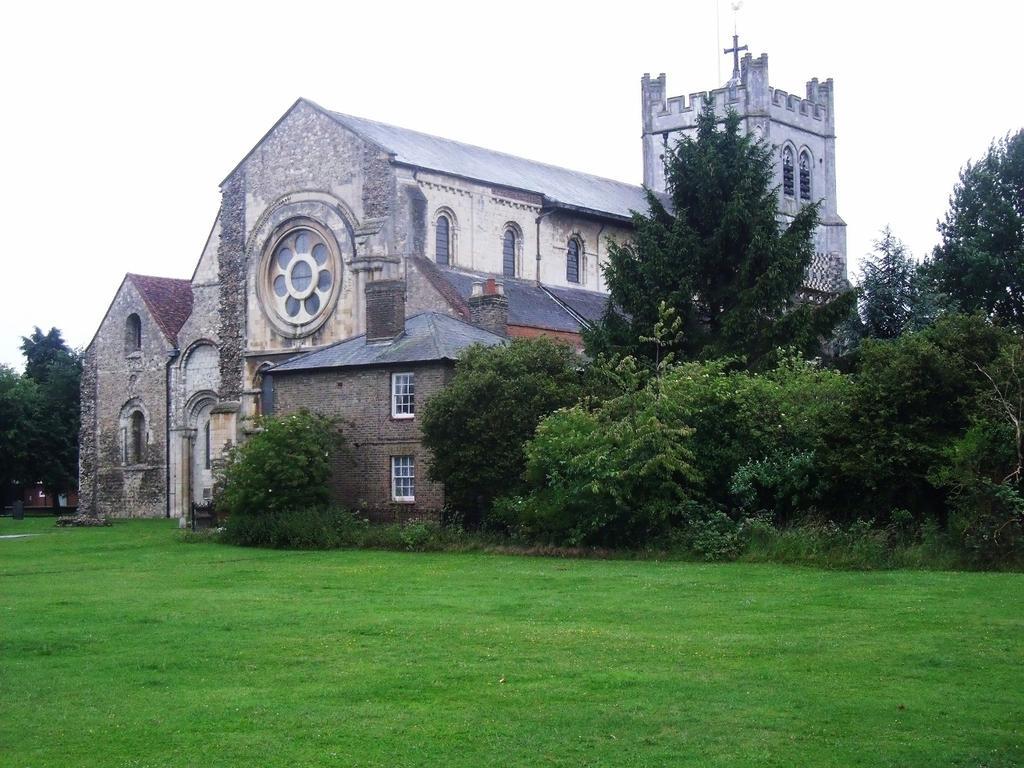In one or two sentences, can you explain what this image depicts? In this picture I can see a building and few trees and I can see grass on the ground and I can see cloudy sky. 